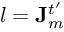<formula> <loc_0><loc_0><loc_500><loc_500>l = J _ { m } ^ { t ^ { \prime } }</formula> 